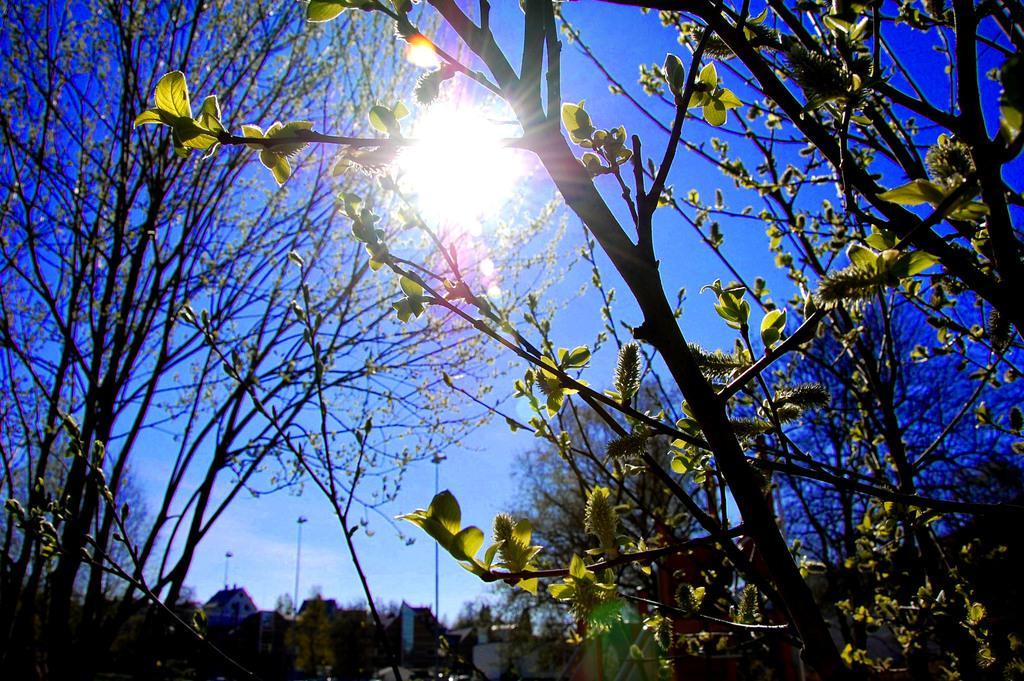Please provide a concise description of this image. In this picture we can see plants in the front, in the background there are trees, we can see the sky at the top of the picture, there is the Sun here. 